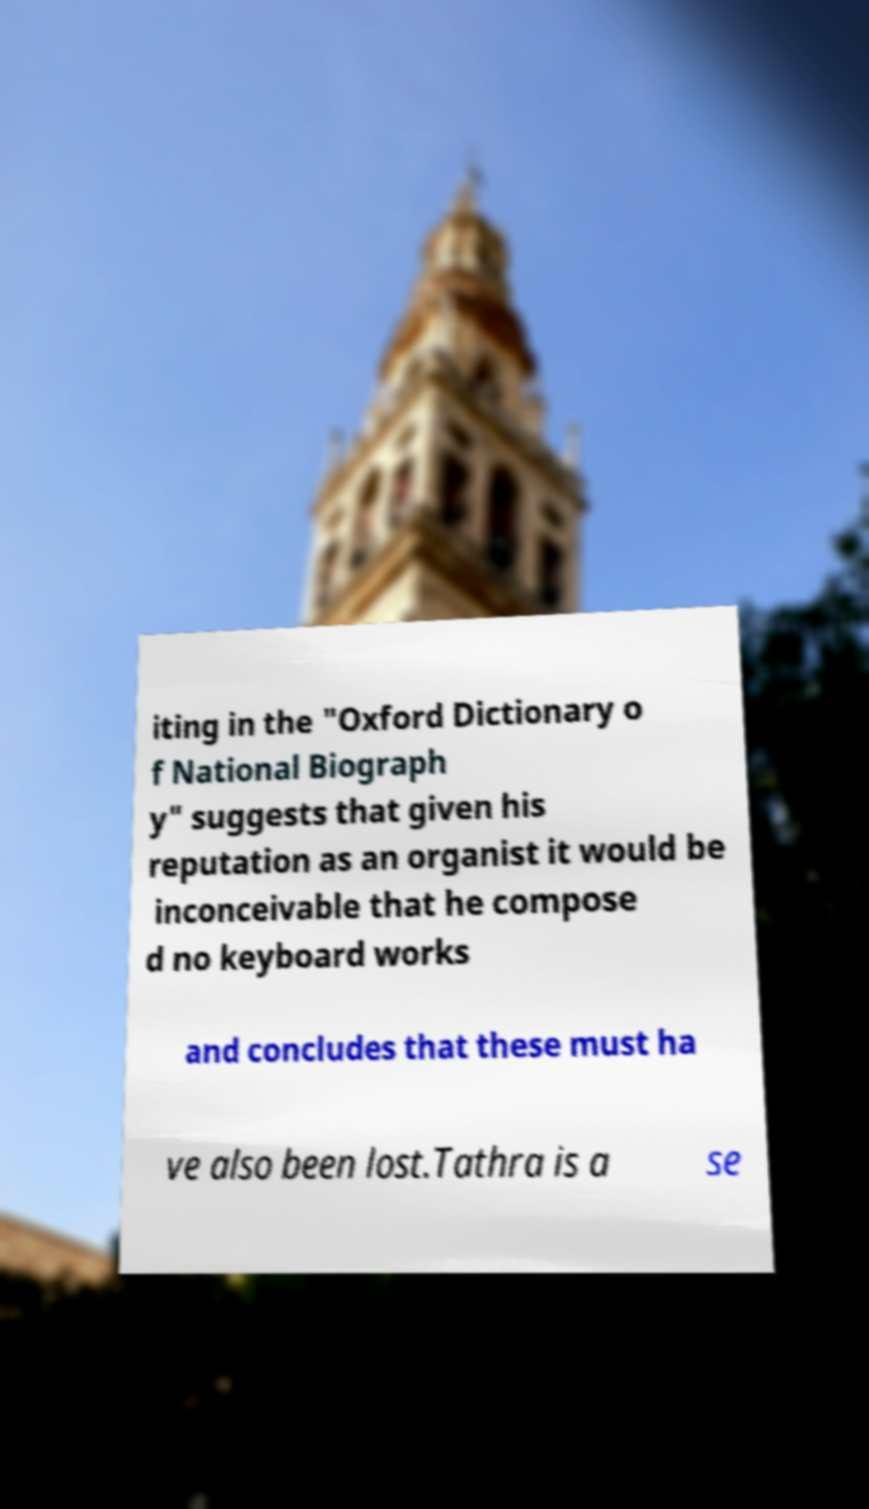I need the written content from this picture converted into text. Can you do that? iting in the "Oxford Dictionary o f National Biograph y" suggests that given his reputation as an organist it would be inconceivable that he compose d no keyboard works and concludes that these must ha ve also been lost.Tathra is a se 